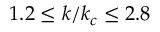Convert formula to latex. <formula><loc_0><loc_0><loc_500><loc_500>1 . 2 \leq k / k _ { c } \leq 2 . 8</formula> 